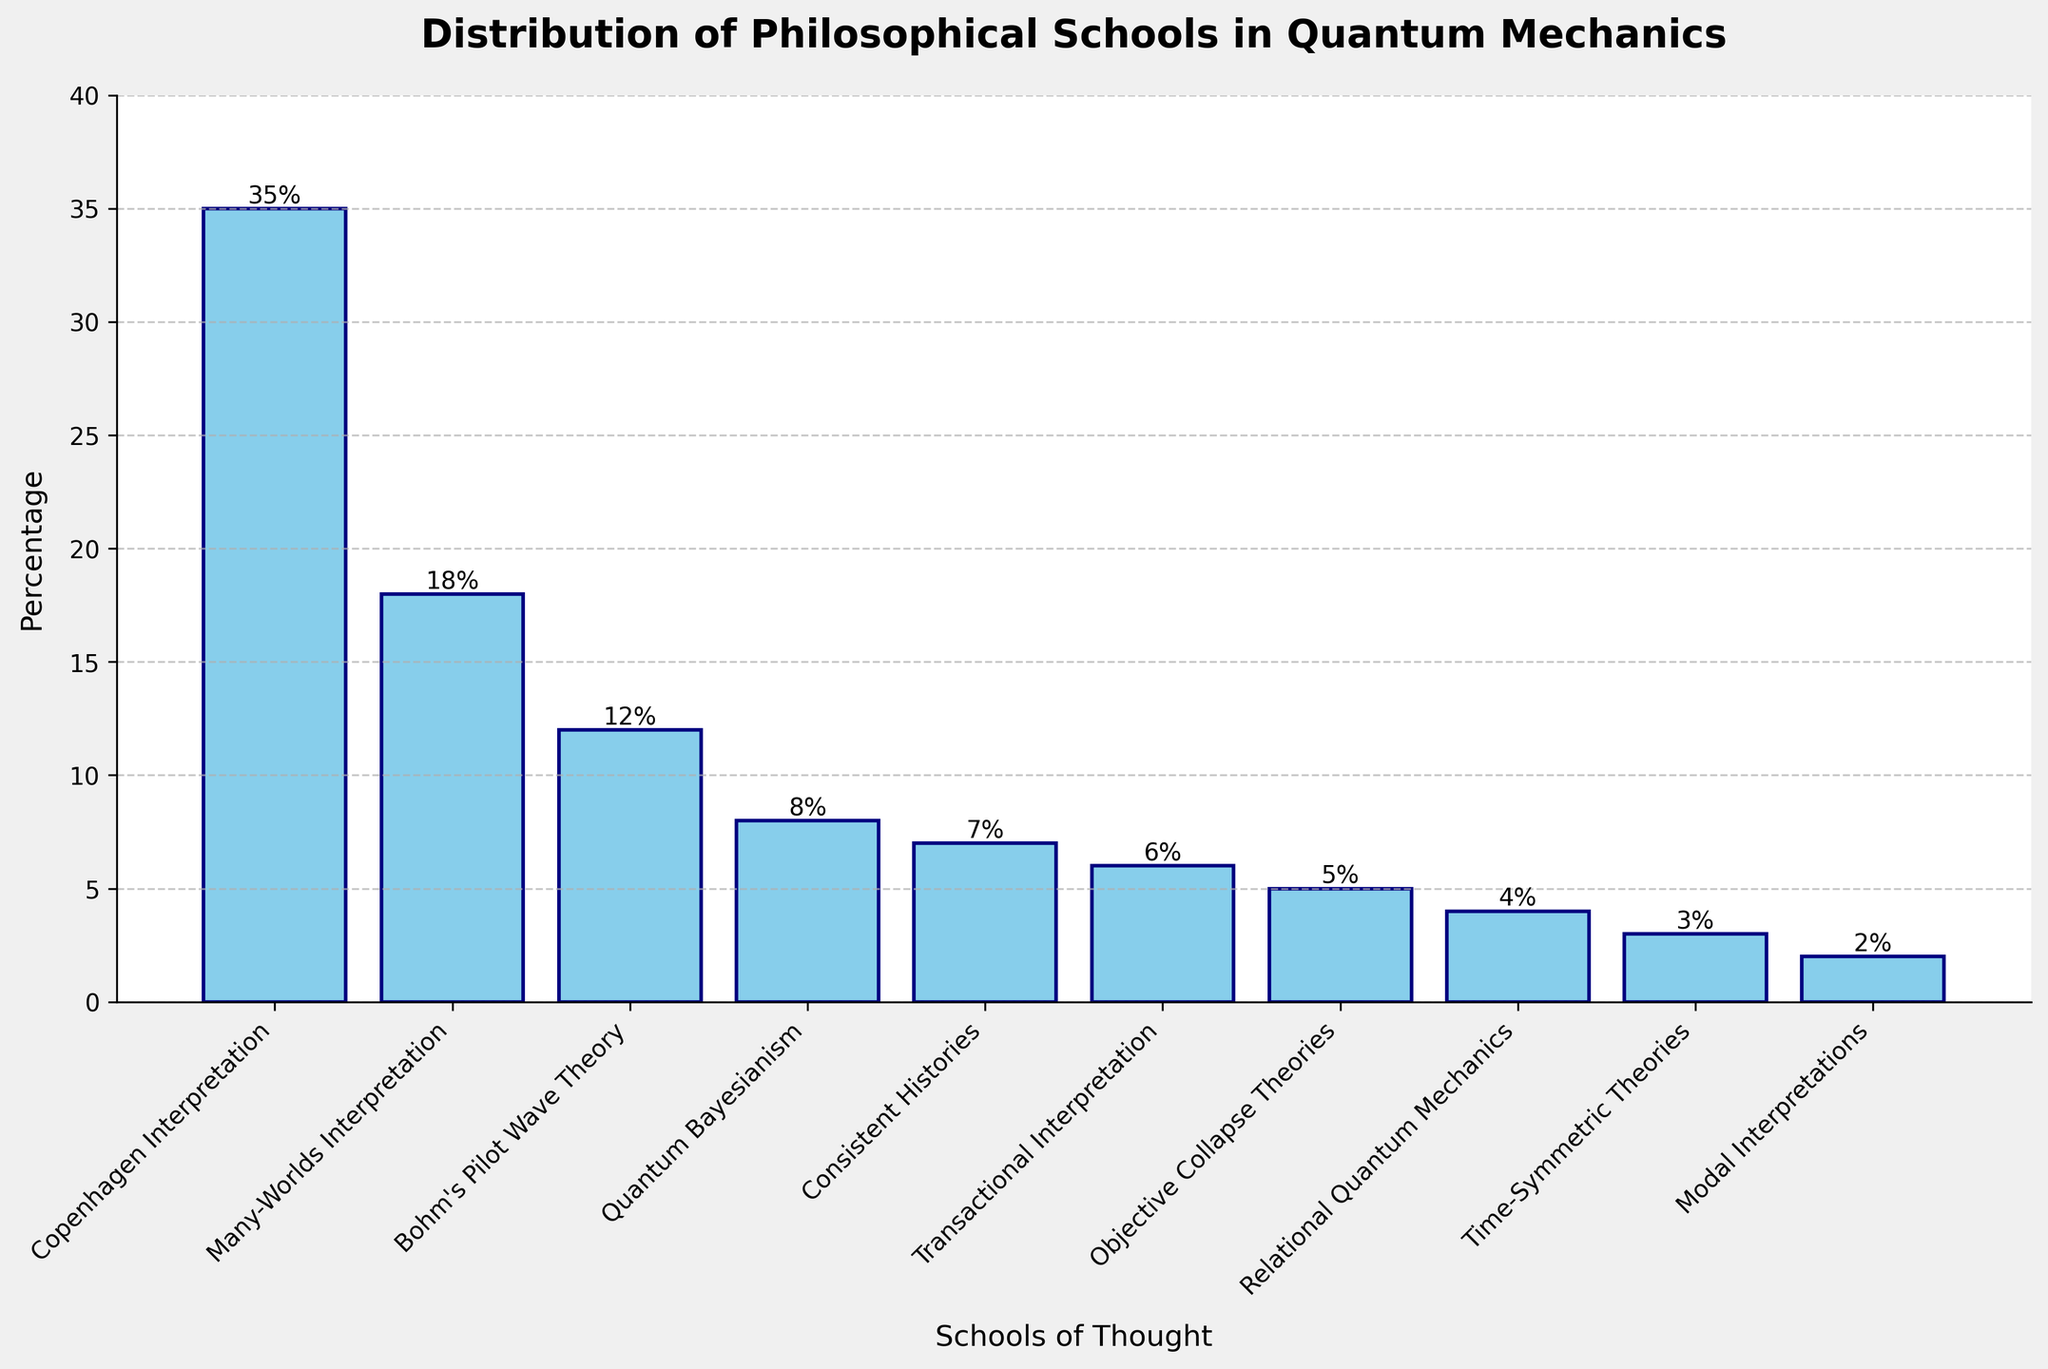What percentage of the philosophical schools is covered by the Copenhagen Interpretation and Many-Worlds Interpretation combined? First, identify the percentage for the Copenhagen Interpretation (35%) and for the Many-Worlds Interpretation (18%). Then, add the two percentages together: 35% + 18% = 53%.
Answer: 53% Which interpretation has the third highest percentage representation? List the interpretations by percentage in descending order: Copenhagen Interpretation (35%), Many-Worlds Interpretation (18%), and Bohm's Pilot Wave Theory (12%). The third highest is Bohm's Pilot Wave Theory.
Answer: Bohm's Pilot Wave Theory What is the difference in percentage between the Quantum Bayesianism and Transactional Interpretation? Identify the percentage for Quantum Bayesianism (8%) and Transactional Interpretation (6%). Subtract the smaller percentage from the larger one: 8% - 6% = 2%.
Answer: 2% How many interpretations have a representation of more than 10%? Identify the interpretations with more than 10%: Copenhagen Interpretation (35%), Many-Worlds Interpretation (18%), and Bohm's Pilot Wave Theory (12%). Count the number of these interpretations: 3 interpretations.
Answer: 3 If you combine Consistent Histories and Objective Collapse Theories, what percentage do they represent? Identify the percentage for Consistent Histories (7%) and Objective Collapse Theories (5%). Add these percentages together: 7% + 5% = 12%.
Answer: 12% Which school has the smallest percentage representation, and what is that percentage? Identify the school with the smallest percentage, which is Modal Interpretations with 2%.
Answer: Modal Interpretations, 2% How does the height of the bar for the Bohm's Pilot Wave Theory compare to that of Objective Collapse Theories? The percentage representation (height) of Bohm's Pilot Wave Theory is 12%, and for Objective Collapse Theories, it is 5%. Bohm's Pilot Wave Theory's bar is taller.
Answer: Bohm's Pilot Wave Theory's bar is taller What is the average percentage representation of all the schools of thought? Sum the percentages of all schools: 35 + 18 + 12 + 8 + 7 + 6 + 5 + 4 + 3 + 2 = 100. There are 10 schools, so divide the total percentage by the number of schools: 100 / 10 = 10%.
Answer: 10% Compare the visual lengths of the bars for Many-Worlds Interpretation and Quantum Bayesianism. Which one is longer? The Many-Worlds Interpretation has a percentage of 18%, and Quantum Bayesianism has 8%. The bar for Many-Worlds Interpretation is longer.
Answer: Many-Worlds Interpretation 